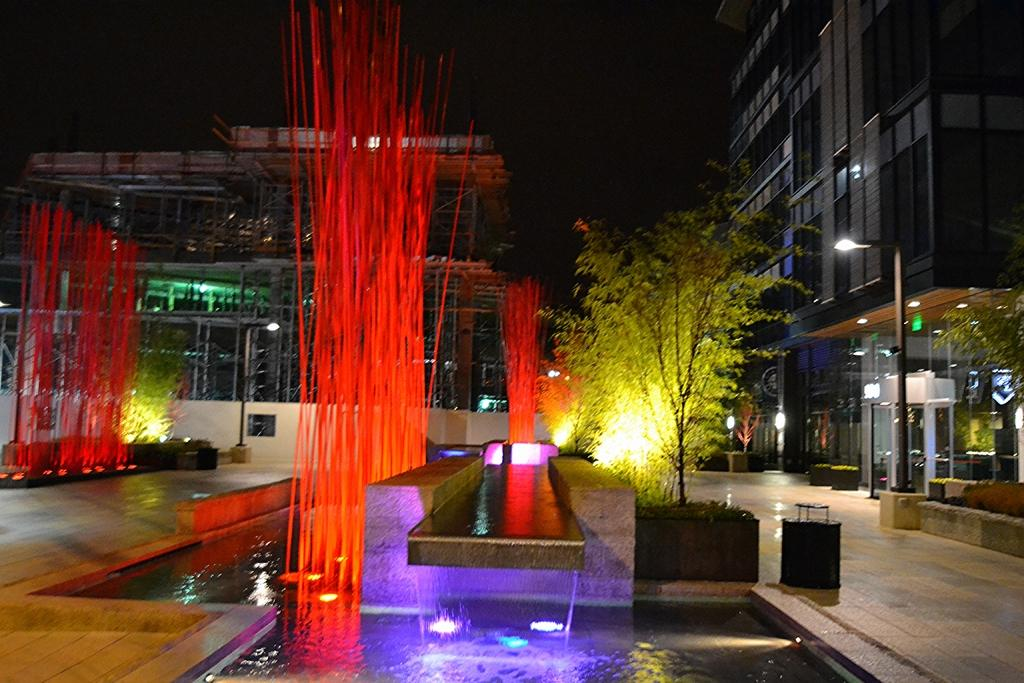What type of structures are present in the image? There are buildings in the image. What features can be observed on the buildings? The buildings have windows and electric lights. What type of natural elements are visible in the image? There are plants and water visible in the image. Are there any additional objects or decorations in the image? Yes, there are decorative objects in the image. How do the boys in the image express their pain? There are no boys present in the image, so it is not possible to answer this question. 